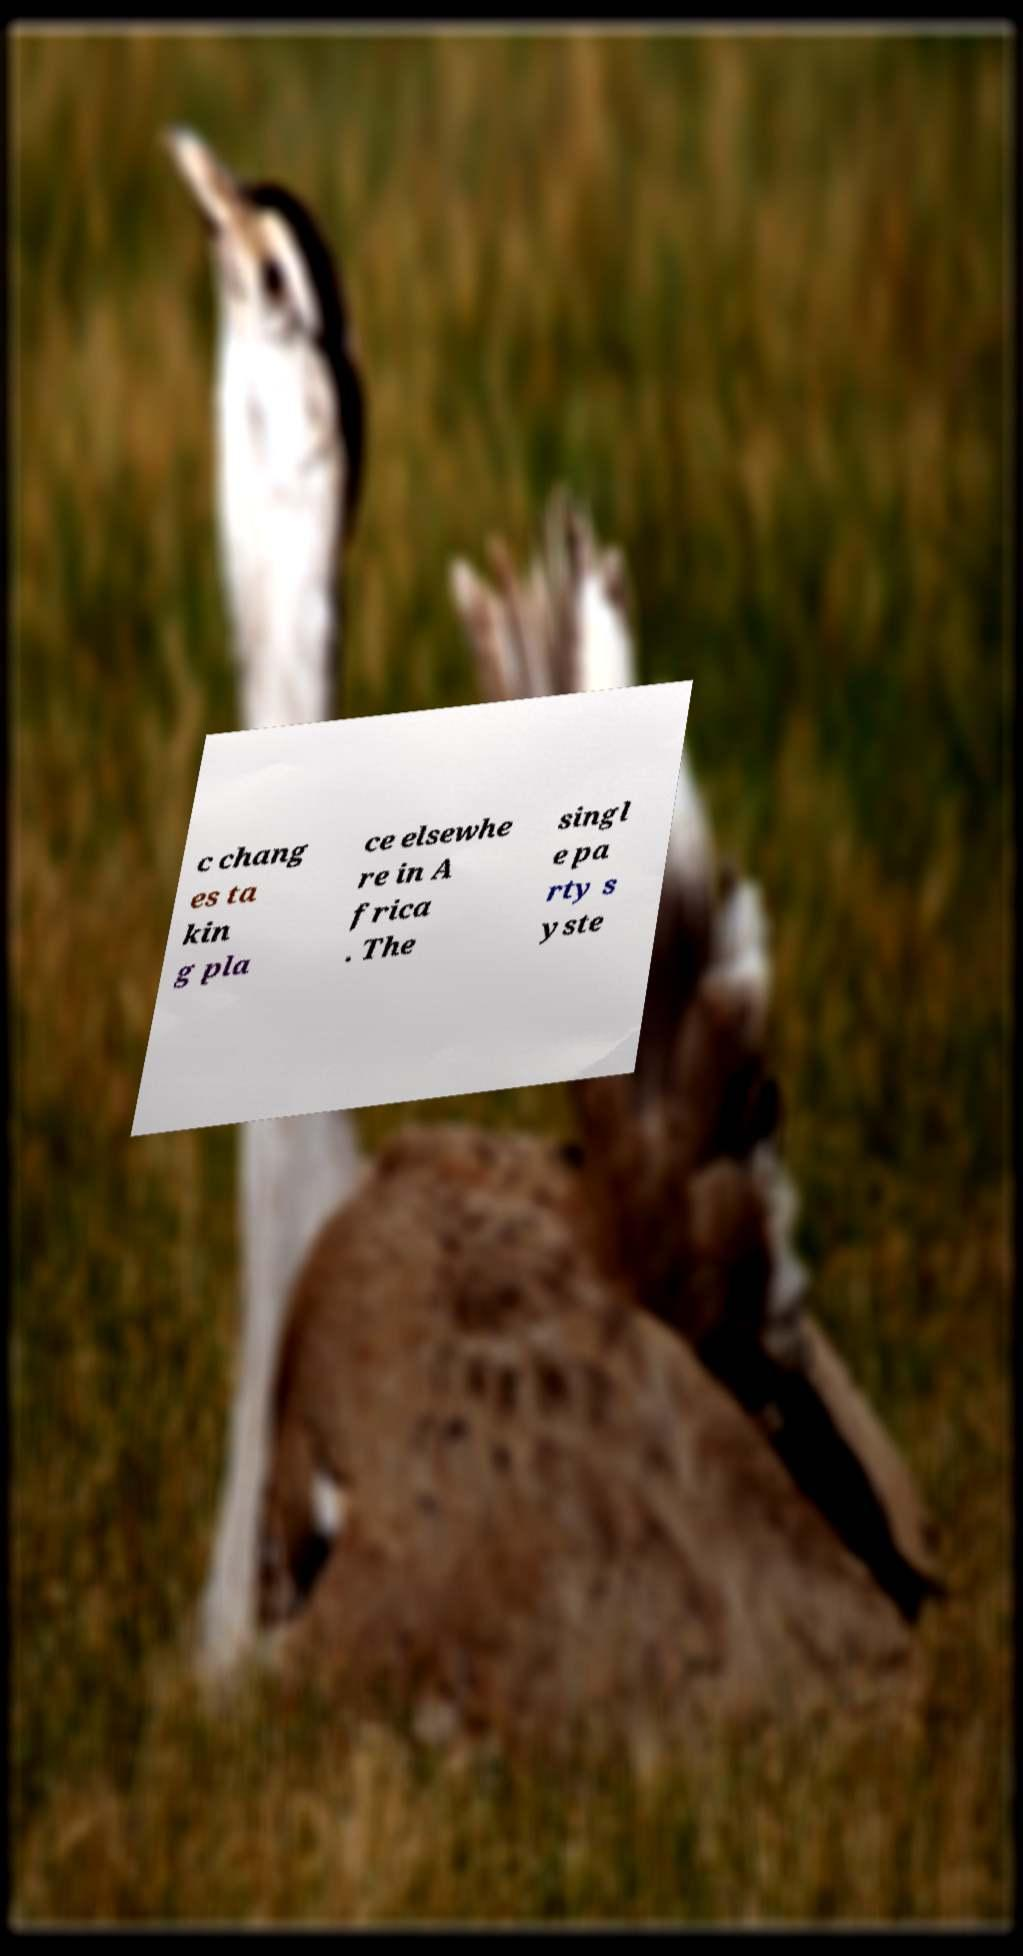I need the written content from this picture converted into text. Can you do that? c chang es ta kin g pla ce elsewhe re in A frica . The singl e pa rty s yste 